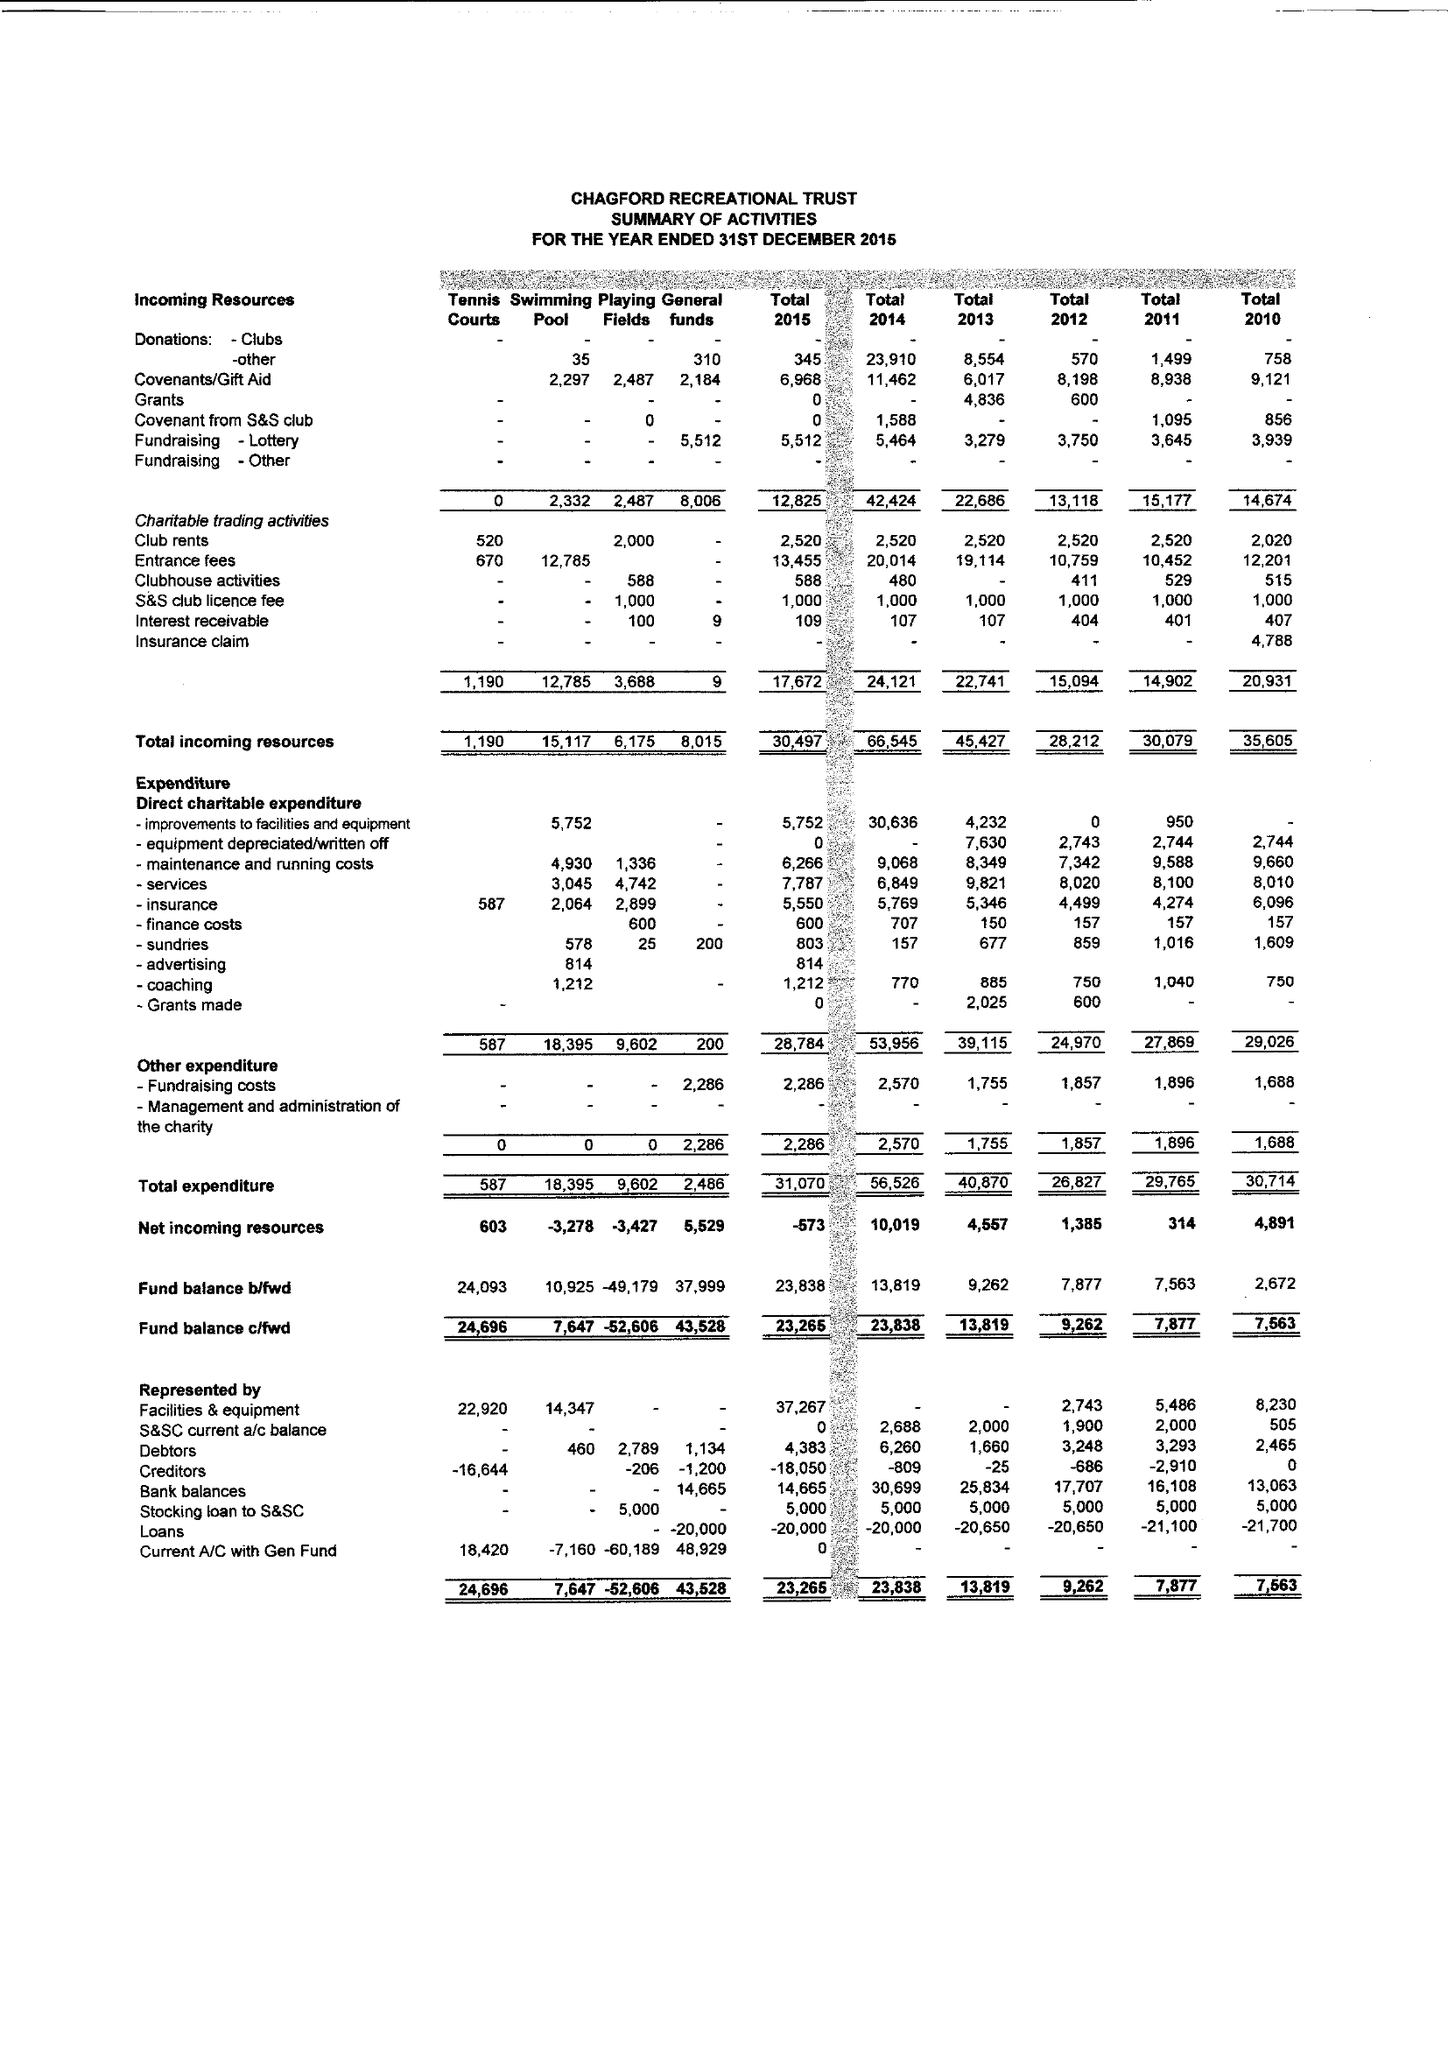What is the value for the address__post_town?
Answer the question using a single word or phrase. NEWTON ABBOT 